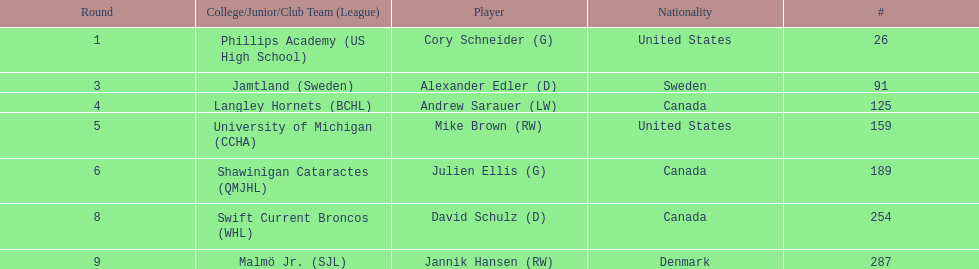Which player was the first player to be drafted? Cory Schneider (G). 